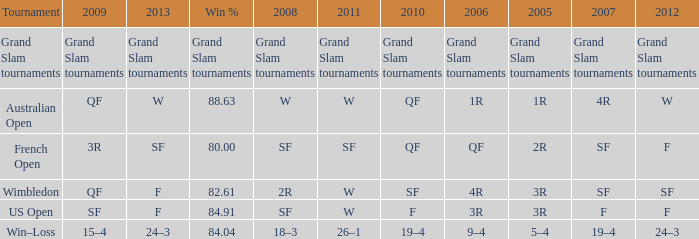What in 2007 has a 2010 of qf, and a 2012 of w? 4R. 